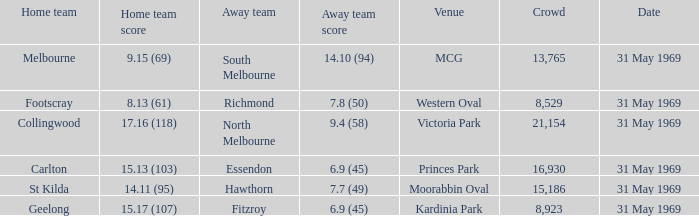In the game where the home team scored 15.17 (107), who was the away team? Fitzroy. Could you parse the entire table as a dict? {'header': ['Home team', 'Home team score', 'Away team', 'Away team score', 'Venue', 'Crowd', 'Date'], 'rows': [['Melbourne', '9.15 (69)', 'South Melbourne', '14.10 (94)', 'MCG', '13,765', '31 May 1969'], ['Footscray', '8.13 (61)', 'Richmond', '7.8 (50)', 'Western Oval', '8,529', '31 May 1969'], ['Collingwood', '17.16 (118)', 'North Melbourne', '9.4 (58)', 'Victoria Park', '21,154', '31 May 1969'], ['Carlton', '15.13 (103)', 'Essendon', '6.9 (45)', 'Princes Park', '16,930', '31 May 1969'], ['St Kilda', '14.11 (95)', 'Hawthorn', '7.7 (49)', 'Moorabbin Oval', '15,186', '31 May 1969'], ['Geelong', '15.17 (107)', 'Fitzroy', '6.9 (45)', 'Kardinia Park', '8,923', '31 May 1969']]} 